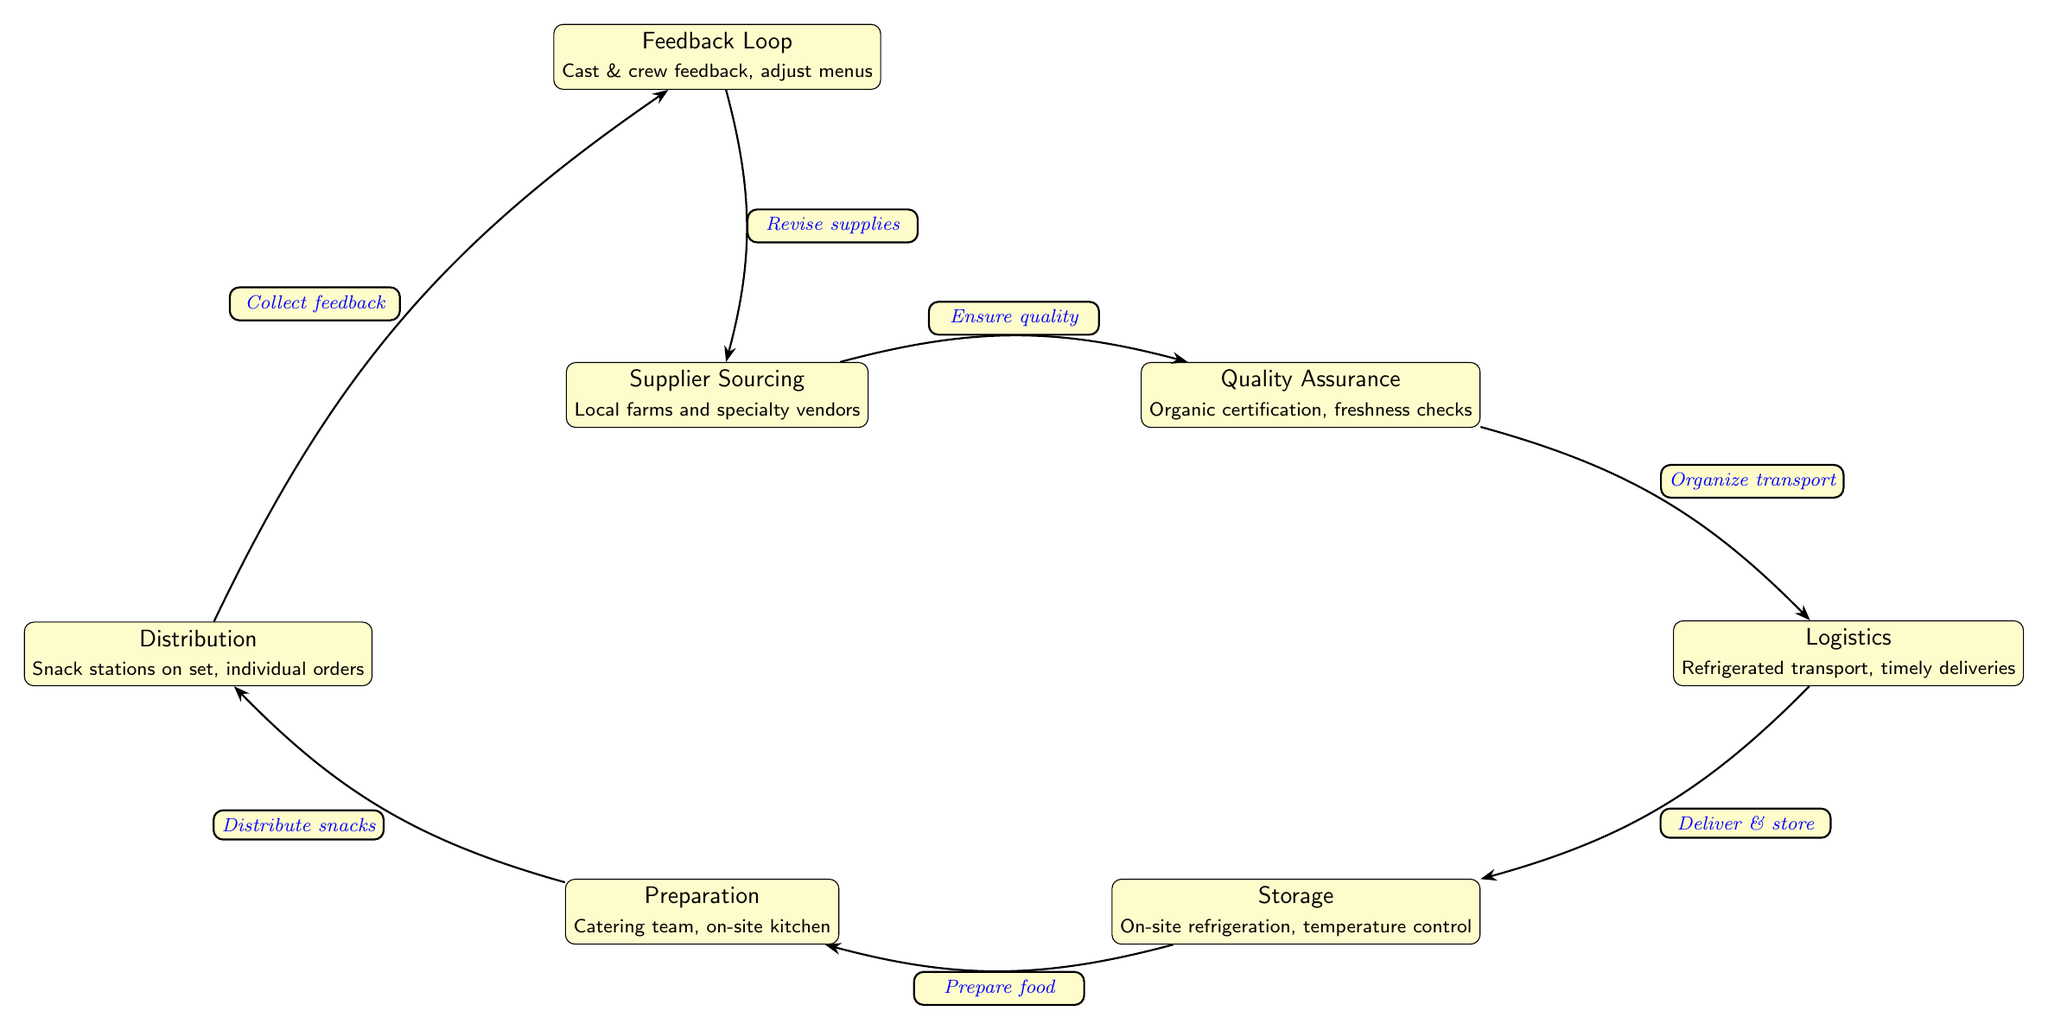What are the sources for suppliers? The suppliers are sourced from local farms and specialty vendors. This information is directly indicated in the first node of the diagram.
Answer: Local farms and specialty vendors How many total nodes are present in the diagram? To find the total number of nodes, count each labeled box within the diagram. There are 7 nodes listed.
Answer: 7 What is the last step before revising supplies? The last step before revising supplies is collecting feedback from the cast and crew. This is stated in the edge leading to the feedback loop.
Answer: Collect feedback What type of transport is organized for logistics? The type of transport organized for logistics is refrigerated transport, which ensures the quality and freshness of the snacks. This is mentioned in the logistics node.
Answer: Refrigerated transport Which node is directly above the preparation node? The node directly above the preparation node is the storage node, as shown in the structure of the diagram.
Answer: Storage What happens after the distribution of snacks? After distributing snacks, a feedback loop is initiated where feedback from the cast and crew is collected to adjust the menus. This is a cyclical process as depicted in the diagram.
Answer: Collect feedback How many edges connect the nodes in the diagram? To determine the number of edges, count the arrows connecting each node. There are 6 connecting edges indicated.
Answer: 6 What ensures the quality in the supplier sourcing process? Quality assurance processes, such as organic certification and freshness checks, ensure the quality in the supplier sourcing process. This is stated in the quality assurance node.
Answer: Organic certification, freshness checks 